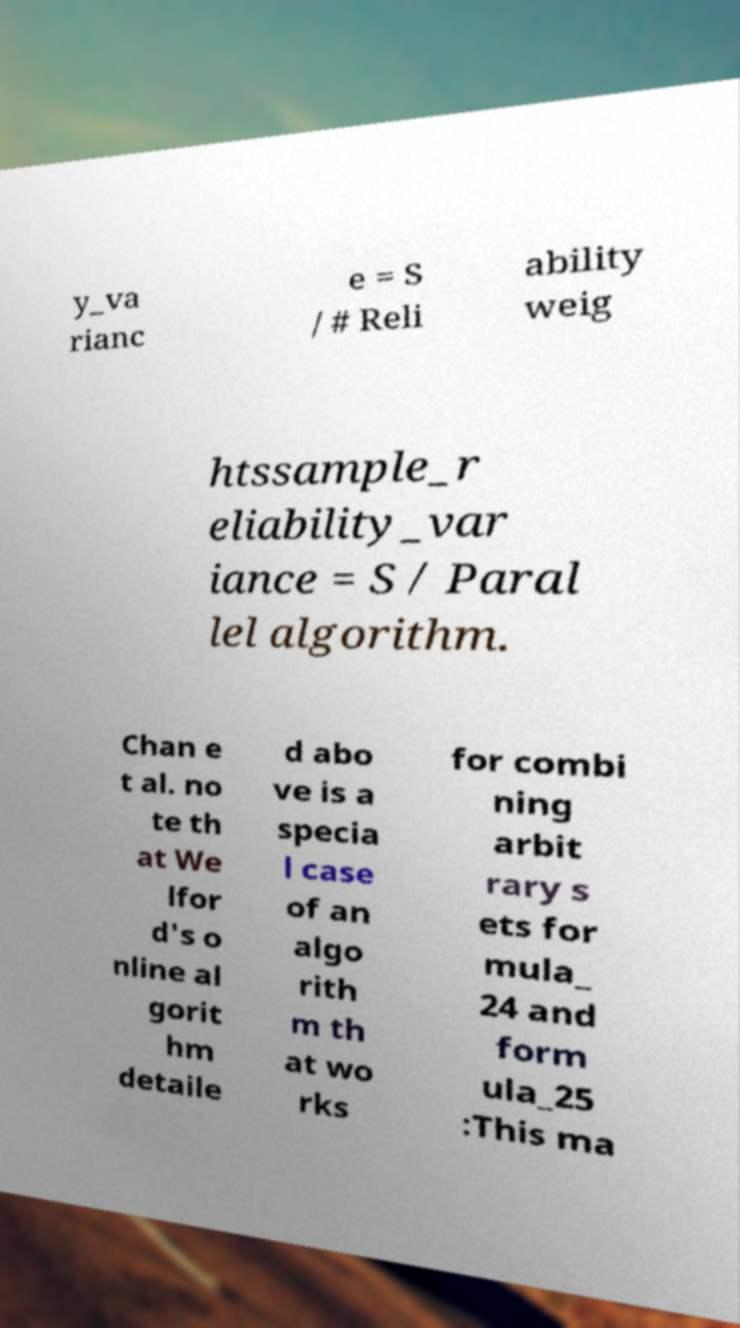I need the written content from this picture converted into text. Can you do that? y_va rianc e = S / # Reli ability weig htssample_r eliability_var iance = S / Paral lel algorithm. Chan e t al. no te th at We lfor d's o nline al gorit hm detaile d abo ve is a specia l case of an algo rith m th at wo rks for combi ning arbit rary s ets for mula_ 24 and form ula_25 :This ma 